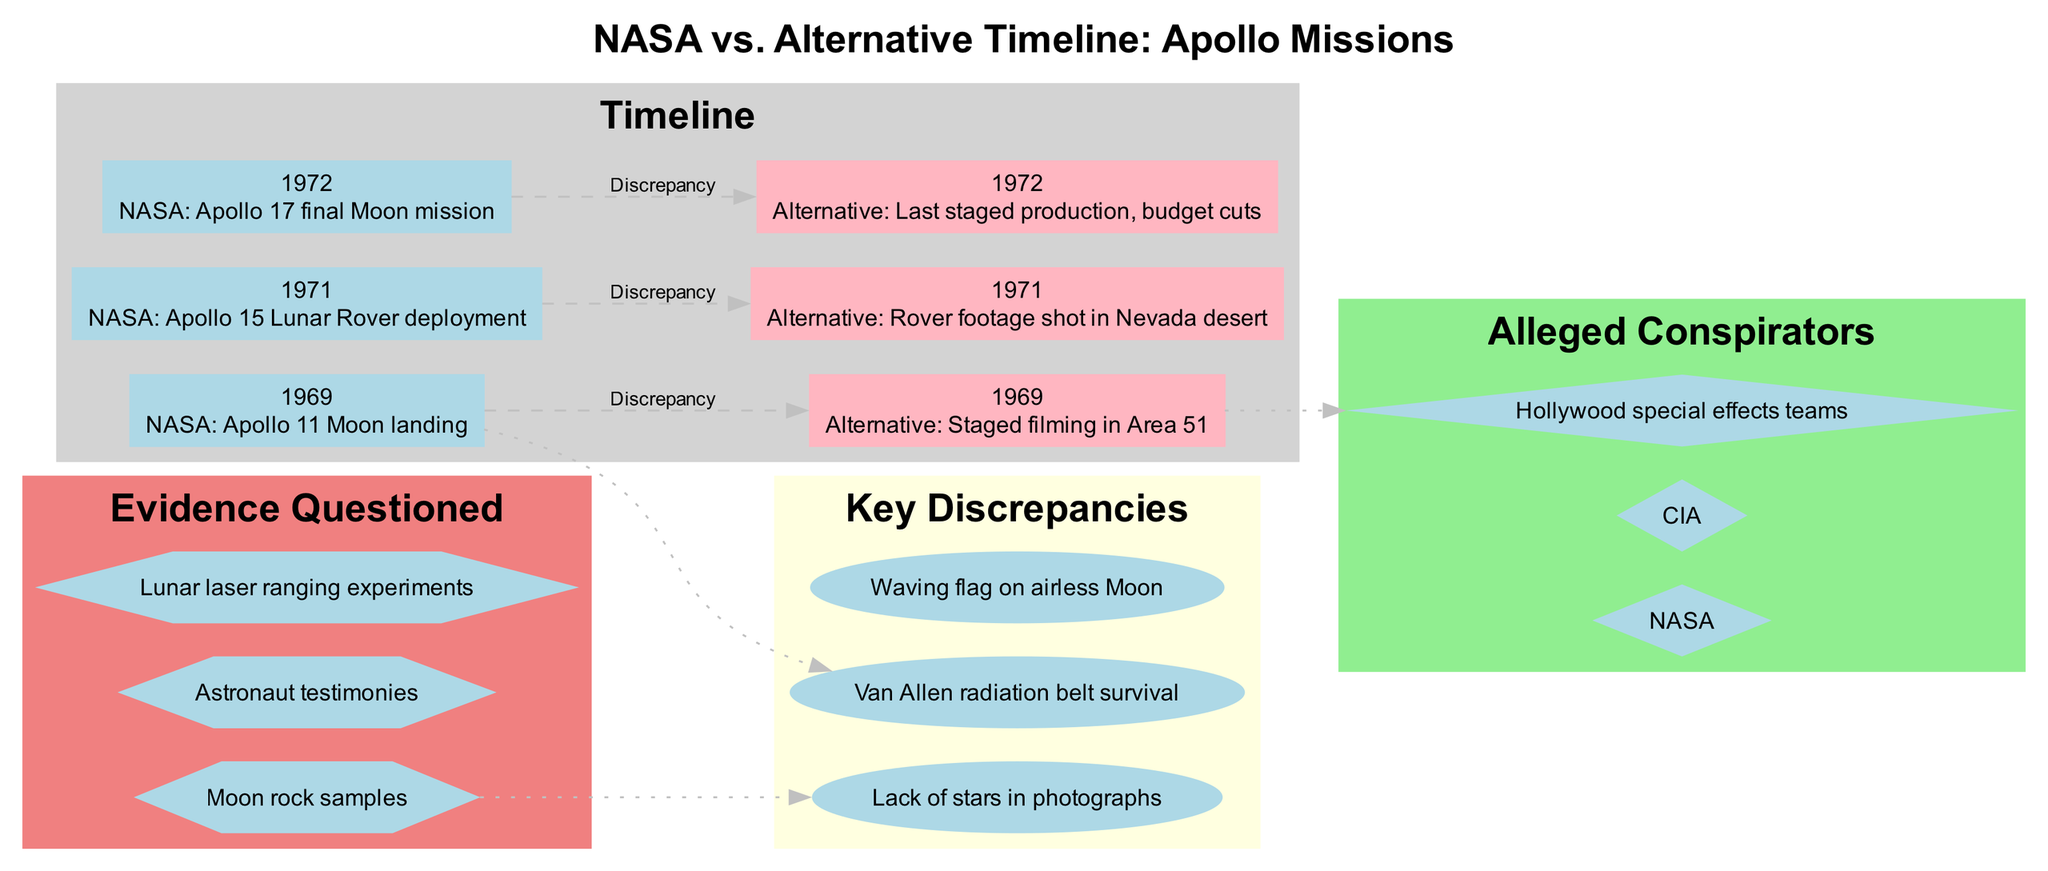What significant event occurred in 1969 according to NASA? The diagram shows that the event listed under NASA for the year 1969 is "Apollo 11 Moon landing." This information is directly stated in the timeline section of the diagram.
Answer: Apollo 11 Moon landing What is the alternative theory proposed for the 1971 Apollo 15 mission? The diagram indicates that the alternative for the Apollo 15 mission in 1971 is "Rover footage shot in Nevada desert." This is found in the timeline related to that year.
Answer: Rover footage shot in Nevada desert How many key discrepancies are listed in the diagram? The key discrepancies section of the diagram lists three specific discrepancies, which can be counted from the visual.
Answer: 3 Which organization is mentioned as an alleged conspirator? The diagram lists "NASA" as one of the alleged conspirators in the cluster of alleged conspirators. This information is directly taken from the respective section in the diagram.
Answer: NASA What connection is illustrated between the 1969 NASA event and a key discrepancy? According to the diagram, a dotted line connects the NASA event in 1969 ("Apollo 11 Moon landing") to the first key discrepancy, which is "Van Allen radiation belt survival." This is an explicit connection shown in the visual layout.
Answer: Van Allen radiation belt survival What shape represents the key discrepancies in the diagram? The diagram uses an ellipse shape to represent the key discrepancies, as specified in the visual structure and attributes provided for that section.
Answer: Ellipse Which year corresponds to the last Apollo mission according to NASA? The timeline in the diagram shows that the last Apollo mission according to NASA occurred in 1972, as indicated in the event listed for that year.
Answer: 1972 How many alleged conspirators are presented in the diagram? The diagram presents three alleged conspirators, which can be counted visually from the cluster labeled "Alleged Conspirators."
Answer: 3 Which specific theory claims that the Apollo 17 mission was the last staged production? The alternative theory for the Apollo 17 mission listed in the timeline states it was "Last staged production, budget cuts." This sentence can be directly referenced in the timeline information.
Answer: Last staged production, budget cuts 